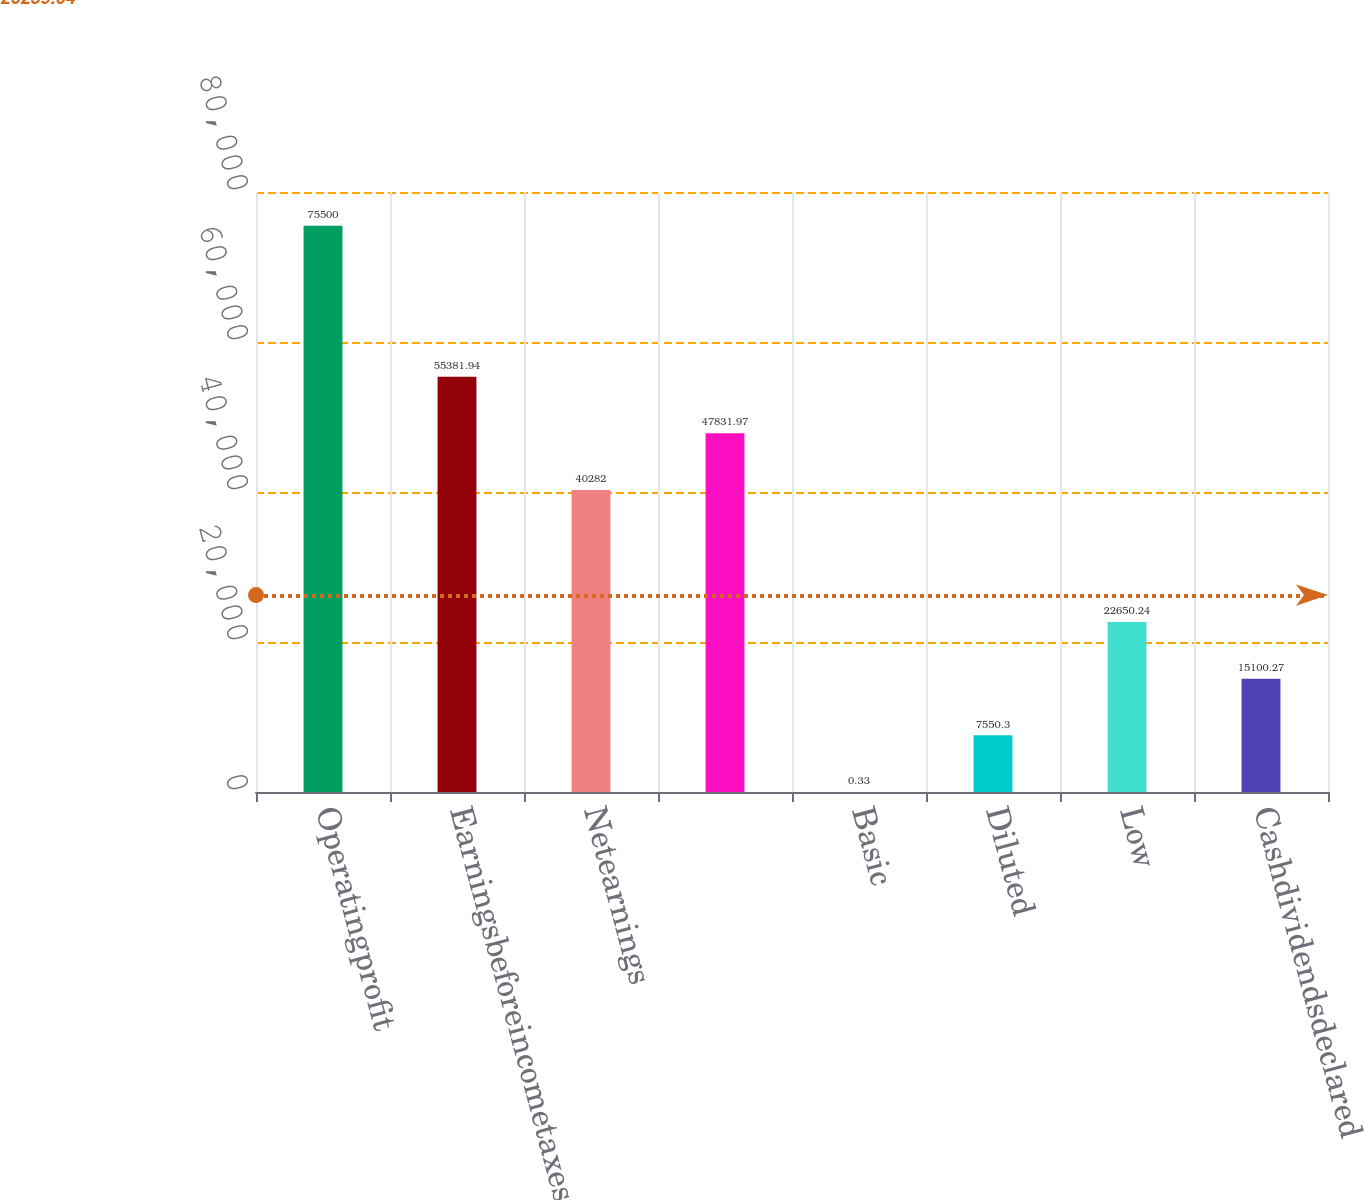Convert chart to OTSL. <chart><loc_0><loc_0><loc_500><loc_500><bar_chart><fcel>Operatingprofit<fcel>Earningsbeforeincometaxes<fcel>Netearnings<fcel>Unnamed: 3<fcel>Basic<fcel>Diluted<fcel>Low<fcel>Cashdividendsdeclared<nl><fcel>75500<fcel>55381.9<fcel>40282<fcel>47832<fcel>0.33<fcel>7550.3<fcel>22650.2<fcel>15100.3<nl></chart> 